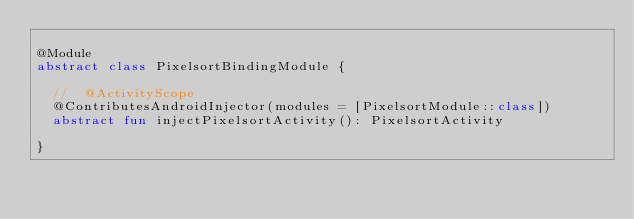<code> <loc_0><loc_0><loc_500><loc_500><_Kotlin_>
@Module
abstract class PixelsortBindingModule {

  //  @ActivityScope
  @ContributesAndroidInjector(modules = [PixelsortModule::class])
  abstract fun injectPixelsortActivity(): PixelsortActivity

}</code> 